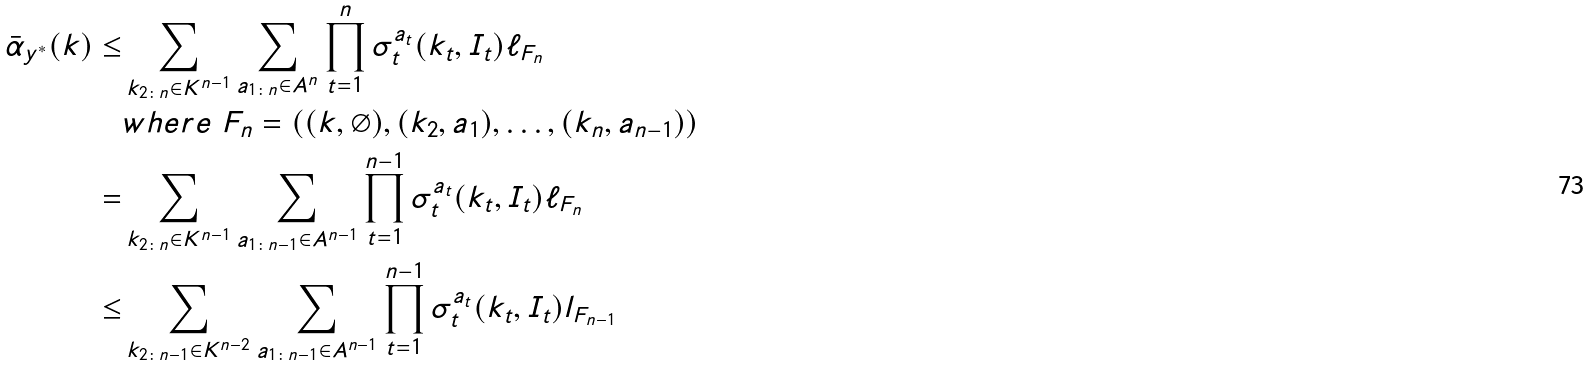Convert formula to latex. <formula><loc_0><loc_0><loc_500><loc_500>\bar { \alpha } _ { y ^ { * } } ( k ) \leq & \sum _ { k _ { 2 \colon n } \in K ^ { n - 1 } } \sum _ { a _ { 1 \colon n } \in A ^ { n } } \prod _ { t = 1 } ^ { n } \sigma _ { t } ^ { a _ { t } } ( k _ { t } , I _ { t } ) \ell _ { F _ { n } } \\ & w h e r e \ F _ { n } = ( ( k , \emptyset ) , ( k _ { 2 } , a _ { 1 } ) , \dots , ( k _ { n } , a _ { n - 1 } ) ) \\ = & \sum _ { k _ { 2 \colon n } \in K ^ { n - 1 } } \sum _ { a _ { 1 \colon n - 1 } \in A ^ { n - 1 } } \prod _ { t = 1 } ^ { n - 1 } \sigma _ { t } ^ { a _ { t } } ( k _ { t } , I _ { t } ) \ell _ { F _ { n } } \\ \leq & \sum _ { k _ { 2 \colon n - 1 } \in K ^ { n - 2 } } \sum _ { a _ { 1 \colon n - 1 } \in A ^ { n - 1 } } \prod _ { t = 1 } ^ { n - 1 } \sigma _ { t } ^ { a _ { t } } ( k _ { t } , I _ { t } ) l _ { F _ { n - 1 } }</formula> 